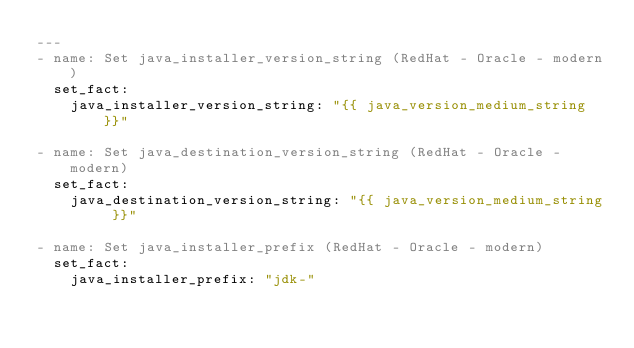<code> <loc_0><loc_0><loc_500><loc_500><_YAML_>---
- name: Set java_installer_version_string (RedHat - Oracle - modern)
  set_fact:
    java_installer_version_string: "{{ java_version_medium_string }}"

- name: Set java_destination_version_string (RedHat - Oracle - modern)
  set_fact:
    java_destination_version_string: "{{ java_version_medium_string }}"

- name: Set java_installer_prefix (RedHat - Oracle - modern)
  set_fact:
    java_installer_prefix: "jdk-"
</code> 